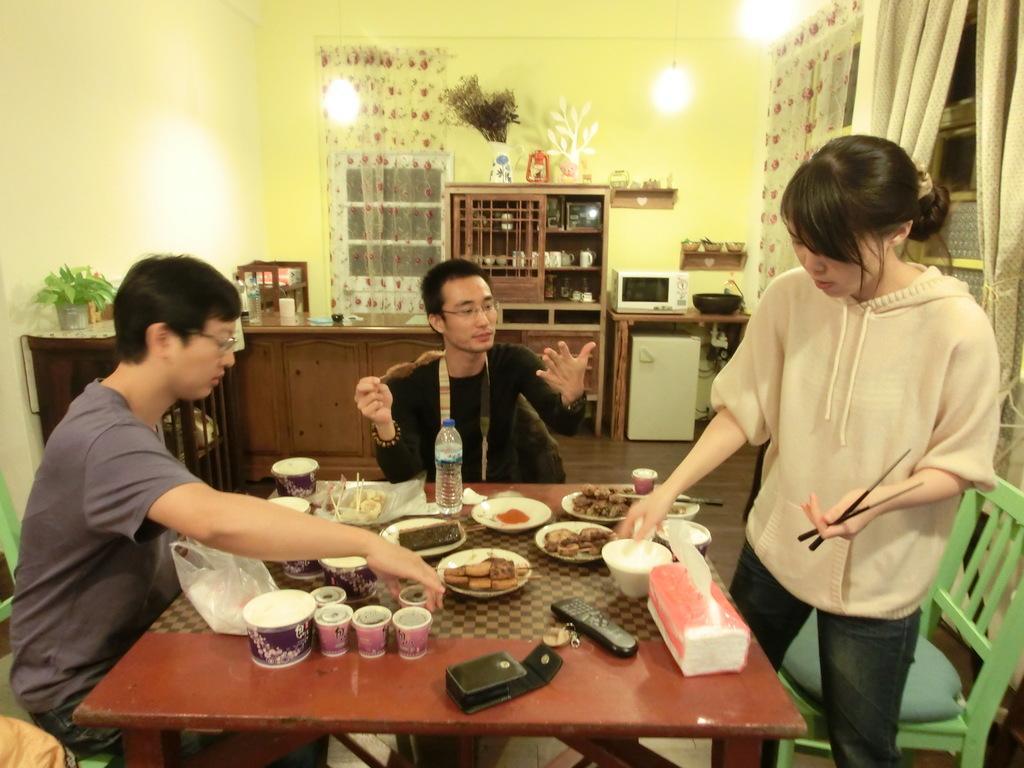Can you describe this image briefly? In the image we can see three persons. On the right the woman,she is standing. And the two persons were sitting on the chair around the table. On table we can see tissue paper,bowl,wallet,remote,key,glasses,plastic cover,water bottle and food item. In the background there is a wall,curtain,table ,top,microwave etc. 